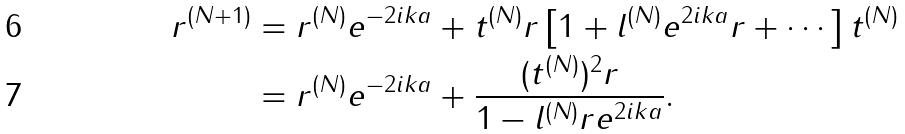Convert formula to latex. <formula><loc_0><loc_0><loc_500><loc_500>r ^ { ( N + 1 ) } & = r ^ { ( N ) } e ^ { - 2 i k a } + t ^ { ( N ) } r \left [ 1 + l ^ { ( N ) } e ^ { 2 i k a } r + \cdots \right ] t ^ { ( N ) } \\ & = r ^ { ( N ) } e ^ { - 2 i k a } + \frac { ( t ^ { ( N ) } ) ^ { 2 } r } { 1 - l ^ { ( N ) } r e ^ { 2 i k a } } .</formula> 